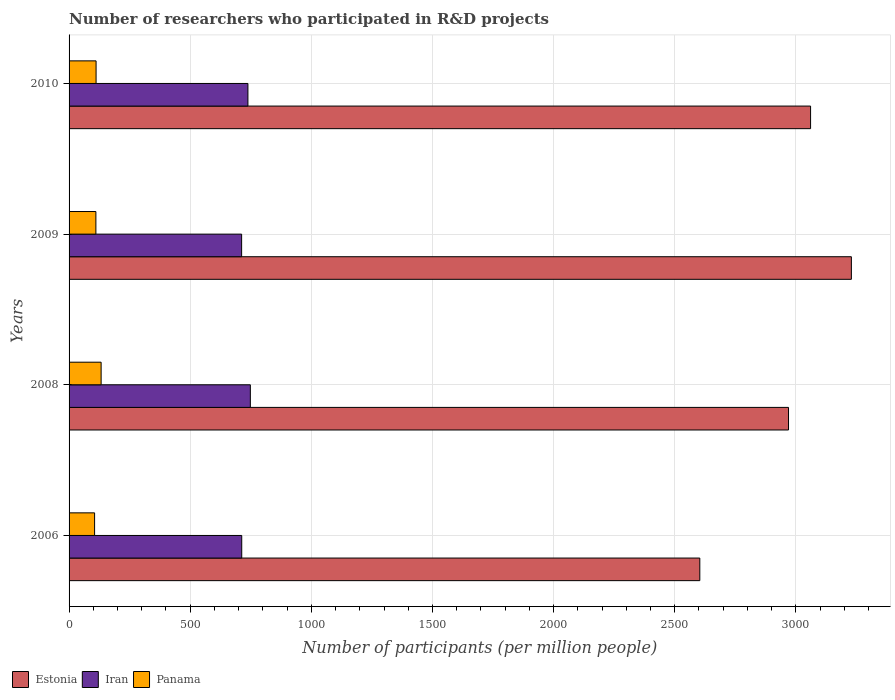Are the number of bars per tick equal to the number of legend labels?
Give a very brief answer. Yes. How many bars are there on the 4th tick from the top?
Provide a succinct answer. 3. What is the number of researchers who participated in R&D projects in Estonia in 2008?
Make the answer very short. 2969.53. Across all years, what is the maximum number of researchers who participated in R&D projects in Panama?
Provide a short and direct response. 132.34. Across all years, what is the minimum number of researchers who participated in R&D projects in Panama?
Your answer should be very brief. 105.37. In which year was the number of researchers who participated in R&D projects in Panama maximum?
Give a very brief answer. 2008. In which year was the number of researchers who participated in R&D projects in Iran minimum?
Ensure brevity in your answer.  2009. What is the total number of researchers who participated in R&D projects in Estonia in the graph?
Give a very brief answer. 1.19e+04. What is the difference between the number of researchers who participated in R&D projects in Estonia in 2009 and that in 2010?
Give a very brief answer. 168.4. What is the difference between the number of researchers who participated in R&D projects in Estonia in 2009 and the number of researchers who participated in R&D projects in Panama in 2008?
Your answer should be compact. 3096.67. What is the average number of researchers who participated in R&D projects in Estonia per year?
Your answer should be compact. 2965.65. In the year 2008, what is the difference between the number of researchers who participated in R&D projects in Estonia and number of researchers who participated in R&D projects in Iran?
Offer a very short reply. 2221.33. What is the ratio of the number of researchers who participated in R&D projects in Iran in 2006 to that in 2009?
Give a very brief answer. 1. Is the number of researchers who participated in R&D projects in Iran in 2009 less than that in 2010?
Ensure brevity in your answer.  Yes. What is the difference between the highest and the second highest number of researchers who participated in R&D projects in Iran?
Give a very brief answer. 10.02. What is the difference between the highest and the lowest number of researchers who participated in R&D projects in Estonia?
Make the answer very short. 625.57. In how many years, is the number of researchers who participated in R&D projects in Panama greater than the average number of researchers who participated in R&D projects in Panama taken over all years?
Provide a succinct answer. 1. What does the 2nd bar from the top in 2006 represents?
Offer a terse response. Iran. What does the 2nd bar from the bottom in 2010 represents?
Your response must be concise. Iran. Is it the case that in every year, the sum of the number of researchers who participated in R&D projects in Estonia and number of researchers who participated in R&D projects in Iran is greater than the number of researchers who participated in R&D projects in Panama?
Your answer should be very brief. Yes. How many years are there in the graph?
Your answer should be very brief. 4. What is the difference between two consecutive major ticks on the X-axis?
Make the answer very short. 500. Are the values on the major ticks of X-axis written in scientific E-notation?
Ensure brevity in your answer.  No. Does the graph contain any zero values?
Ensure brevity in your answer.  No. Where does the legend appear in the graph?
Offer a terse response. Bottom left. What is the title of the graph?
Your answer should be compact. Number of researchers who participated in R&D projects. What is the label or title of the X-axis?
Make the answer very short. Number of participants (per million people). What is the label or title of the Y-axis?
Give a very brief answer. Years. What is the Number of participants (per million people) of Estonia in 2006?
Offer a very short reply. 2603.44. What is the Number of participants (per million people) in Iran in 2006?
Keep it short and to the point. 712.69. What is the Number of participants (per million people) of Panama in 2006?
Your answer should be compact. 105.37. What is the Number of participants (per million people) in Estonia in 2008?
Provide a short and direct response. 2969.53. What is the Number of participants (per million people) in Iran in 2008?
Your response must be concise. 748.21. What is the Number of participants (per million people) of Panama in 2008?
Your answer should be compact. 132.34. What is the Number of participants (per million people) in Estonia in 2009?
Ensure brevity in your answer.  3229.01. What is the Number of participants (per million people) of Iran in 2009?
Offer a terse response. 712.22. What is the Number of participants (per million people) in Panama in 2009?
Give a very brief answer. 110.69. What is the Number of participants (per million people) in Estonia in 2010?
Your answer should be very brief. 3060.61. What is the Number of participants (per million people) of Iran in 2010?
Provide a succinct answer. 738.19. What is the Number of participants (per million people) of Panama in 2010?
Offer a very short reply. 111.47. Across all years, what is the maximum Number of participants (per million people) in Estonia?
Offer a very short reply. 3229.01. Across all years, what is the maximum Number of participants (per million people) in Iran?
Keep it short and to the point. 748.21. Across all years, what is the maximum Number of participants (per million people) of Panama?
Your answer should be very brief. 132.34. Across all years, what is the minimum Number of participants (per million people) of Estonia?
Keep it short and to the point. 2603.44. Across all years, what is the minimum Number of participants (per million people) of Iran?
Ensure brevity in your answer.  712.22. Across all years, what is the minimum Number of participants (per million people) of Panama?
Your response must be concise. 105.37. What is the total Number of participants (per million people) of Estonia in the graph?
Make the answer very short. 1.19e+04. What is the total Number of participants (per million people) of Iran in the graph?
Keep it short and to the point. 2911.3. What is the total Number of participants (per million people) of Panama in the graph?
Your response must be concise. 459.87. What is the difference between the Number of participants (per million people) of Estonia in 2006 and that in 2008?
Offer a very short reply. -366.09. What is the difference between the Number of participants (per million people) in Iran in 2006 and that in 2008?
Offer a very short reply. -35.52. What is the difference between the Number of participants (per million people) in Panama in 2006 and that in 2008?
Offer a terse response. -26.97. What is the difference between the Number of participants (per million people) of Estonia in 2006 and that in 2009?
Provide a succinct answer. -625.57. What is the difference between the Number of participants (per million people) in Iran in 2006 and that in 2009?
Ensure brevity in your answer.  0.47. What is the difference between the Number of participants (per million people) in Panama in 2006 and that in 2009?
Keep it short and to the point. -5.32. What is the difference between the Number of participants (per million people) of Estonia in 2006 and that in 2010?
Make the answer very short. -457.17. What is the difference between the Number of participants (per million people) in Iran in 2006 and that in 2010?
Give a very brief answer. -25.5. What is the difference between the Number of participants (per million people) in Panama in 2006 and that in 2010?
Provide a succinct answer. -6.1. What is the difference between the Number of participants (per million people) of Estonia in 2008 and that in 2009?
Offer a terse response. -259.48. What is the difference between the Number of participants (per million people) in Iran in 2008 and that in 2009?
Keep it short and to the point. 35.99. What is the difference between the Number of participants (per million people) of Panama in 2008 and that in 2009?
Your answer should be compact. 21.64. What is the difference between the Number of participants (per million people) of Estonia in 2008 and that in 2010?
Ensure brevity in your answer.  -91.07. What is the difference between the Number of participants (per million people) in Iran in 2008 and that in 2010?
Offer a very short reply. 10.02. What is the difference between the Number of participants (per million people) in Panama in 2008 and that in 2010?
Keep it short and to the point. 20.87. What is the difference between the Number of participants (per million people) in Estonia in 2009 and that in 2010?
Provide a short and direct response. 168.4. What is the difference between the Number of participants (per million people) of Iran in 2009 and that in 2010?
Ensure brevity in your answer.  -25.97. What is the difference between the Number of participants (per million people) of Panama in 2009 and that in 2010?
Offer a very short reply. -0.78. What is the difference between the Number of participants (per million people) in Estonia in 2006 and the Number of participants (per million people) in Iran in 2008?
Ensure brevity in your answer.  1855.23. What is the difference between the Number of participants (per million people) in Estonia in 2006 and the Number of participants (per million people) in Panama in 2008?
Provide a short and direct response. 2471.1. What is the difference between the Number of participants (per million people) in Iran in 2006 and the Number of participants (per million people) in Panama in 2008?
Keep it short and to the point. 580.35. What is the difference between the Number of participants (per million people) in Estonia in 2006 and the Number of participants (per million people) in Iran in 2009?
Keep it short and to the point. 1891.22. What is the difference between the Number of participants (per million people) in Estonia in 2006 and the Number of participants (per million people) in Panama in 2009?
Keep it short and to the point. 2492.75. What is the difference between the Number of participants (per million people) of Iran in 2006 and the Number of participants (per million people) of Panama in 2009?
Make the answer very short. 601.99. What is the difference between the Number of participants (per million people) of Estonia in 2006 and the Number of participants (per million people) of Iran in 2010?
Keep it short and to the point. 1865.25. What is the difference between the Number of participants (per million people) of Estonia in 2006 and the Number of participants (per million people) of Panama in 2010?
Make the answer very short. 2491.97. What is the difference between the Number of participants (per million people) of Iran in 2006 and the Number of participants (per million people) of Panama in 2010?
Provide a succinct answer. 601.22. What is the difference between the Number of participants (per million people) in Estonia in 2008 and the Number of participants (per million people) in Iran in 2009?
Provide a short and direct response. 2257.32. What is the difference between the Number of participants (per million people) in Estonia in 2008 and the Number of participants (per million people) in Panama in 2009?
Offer a very short reply. 2858.84. What is the difference between the Number of participants (per million people) in Iran in 2008 and the Number of participants (per million people) in Panama in 2009?
Keep it short and to the point. 637.51. What is the difference between the Number of participants (per million people) of Estonia in 2008 and the Number of participants (per million people) of Iran in 2010?
Provide a succinct answer. 2231.34. What is the difference between the Number of participants (per million people) in Estonia in 2008 and the Number of participants (per million people) in Panama in 2010?
Provide a short and direct response. 2858.06. What is the difference between the Number of participants (per million people) in Iran in 2008 and the Number of participants (per million people) in Panama in 2010?
Your answer should be very brief. 636.74. What is the difference between the Number of participants (per million people) in Estonia in 2009 and the Number of participants (per million people) in Iran in 2010?
Provide a short and direct response. 2490.82. What is the difference between the Number of participants (per million people) in Estonia in 2009 and the Number of participants (per million people) in Panama in 2010?
Provide a short and direct response. 3117.54. What is the difference between the Number of participants (per million people) of Iran in 2009 and the Number of participants (per million people) of Panama in 2010?
Give a very brief answer. 600.75. What is the average Number of participants (per million people) in Estonia per year?
Your answer should be very brief. 2965.65. What is the average Number of participants (per million people) of Iran per year?
Make the answer very short. 727.82. What is the average Number of participants (per million people) of Panama per year?
Ensure brevity in your answer.  114.97. In the year 2006, what is the difference between the Number of participants (per million people) of Estonia and Number of participants (per million people) of Iran?
Provide a succinct answer. 1890.75. In the year 2006, what is the difference between the Number of participants (per million people) of Estonia and Number of participants (per million people) of Panama?
Make the answer very short. 2498.07. In the year 2006, what is the difference between the Number of participants (per million people) of Iran and Number of participants (per million people) of Panama?
Offer a very short reply. 607.32. In the year 2008, what is the difference between the Number of participants (per million people) in Estonia and Number of participants (per million people) in Iran?
Give a very brief answer. 2221.33. In the year 2008, what is the difference between the Number of participants (per million people) in Estonia and Number of participants (per million people) in Panama?
Ensure brevity in your answer.  2837.2. In the year 2008, what is the difference between the Number of participants (per million people) in Iran and Number of participants (per million people) in Panama?
Provide a short and direct response. 615.87. In the year 2009, what is the difference between the Number of participants (per million people) in Estonia and Number of participants (per million people) in Iran?
Provide a short and direct response. 2516.79. In the year 2009, what is the difference between the Number of participants (per million people) in Estonia and Number of participants (per million people) in Panama?
Keep it short and to the point. 3118.32. In the year 2009, what is the difference between the Number of participants (per million people) of Iran and Number of participants (per million people) of Panama?
Your answer should be compact. 601.52. In the year 2010, what is the difference between the Number of participants (per million people) of Estonia and Number of participants (per million people) of Iran?
Ensure brevity in your answer.  2322.42. In the year 2010, what is the difference between the Number of participants (per million people) in Estonia and Number of participants (per million people) in Panama?
Your response must be concise. 2949.14. In the year 2010, what is the difference between the Number of participants (per million people) in Iran and Number of participants (per million people) in Panama?
Ensure brevity in your answer.  626.72. What is the ratio of the Number of participants (per million people) in Estonia in 2006 to that in 2008?
Provide a succinct answer. 0.88. What is the ratio of the Number of participants (per million people) of Iran in 2006 to that in 2008?
Your response must be concise. 0.95. What is the ratio of the Number of participants (per million people) in Panama in 2006 to that in 2008?
Your answer should be compact. 0.8. What is the ratio of the Number of participants (per million people) in Estonia in 2006 to that in 2009?
Ensure brevity in your answer.  0.81. What is the ratio of the Number of participants (per million people) in Panama in 2006 to that in 2009?
Ensure brevity in your answer.  0.95. What is the ratio of the Number of participants (per million people) in Estonia in 2006 to that in 2010?
Make the answer very short. 0.85. What is the ratio of the Number of participants (per million people) of Iran in 2006 to that in 2010?
Provide a succinct answer. 0.97. What is the ratio of the Number of participants (per million people) of Panama in 2006 to that in 2010?
Offer a very short reply. 0.95. What is the ratio of the Number of participants (per million people) of Estonia in 2008 to that in 2009?
Your answer should be compact. 0.92. What is the ratio of the Number of participants (per million people) in Iran in 2008 to that in 2009?
Your answer should be compact. 1.05. What is the ratio of the Number of participants (per million people) in Panama in 2008 to that in 2009?
Offer a terse response. 1.2. What is the ratio of the Number of participants (per million people) of Estonia in 2008 to that in 2010?
Your response must be concise. 0.97. What is the ratio of the Number of participants (per million people) in Iran in 2008 to that in 2010?
Your answer should be compact. 1.01. What is the ratio of the Number of participants (per million people) of Panama in 2008 to that in 2010?
Ensure brevity in your answer.  1.19. What is the ratio of the Number of participants (per million people) of Estonia in 2009 to that in 2010?
Give a very brief answer. 1.05. What is the ratio of the Number of participants (per million people) in Iran in 2009 to that in 2010?
Keep it short and to the point. 0.96. What is the difference between the highest and the second highest Number of participants (per million people) of Estonia?
Ensure brevity in your answer.  168.4. What is the difference between the highest and the second highest Number of participants (per million people) in Iran?
Provide a short and direct response. 10.02. What is the difference between the highest and the second highest Number of participants (per million people) of Panama?
Your response must be concise. 20.87. What is the difference between the highest and the lowest Number of participants (per million people) in Estonia?
Offer a very short reply. 625.57. What is the difference between the highest and the lowest Number of participants (per million people) of Iran?
Offer a very short reply. 35.99. What is the difference between the highest and the lowest Number of participants (per million people) in Panama?
Give a very brief answer. 26.97. 